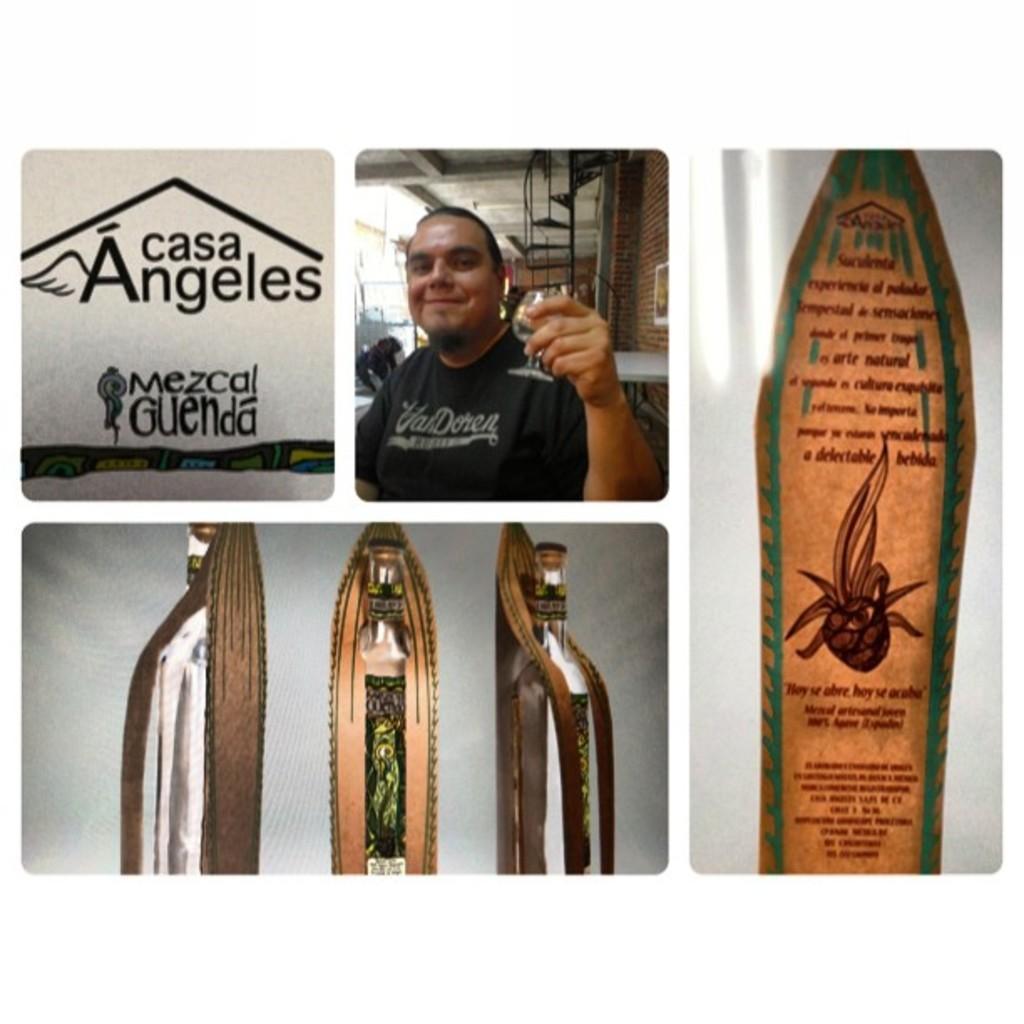Can you describe this image briefly? The image consists of several images,In the second picture there is a man and over the bottom picture there are bottles and over to the last picture there is written script. 